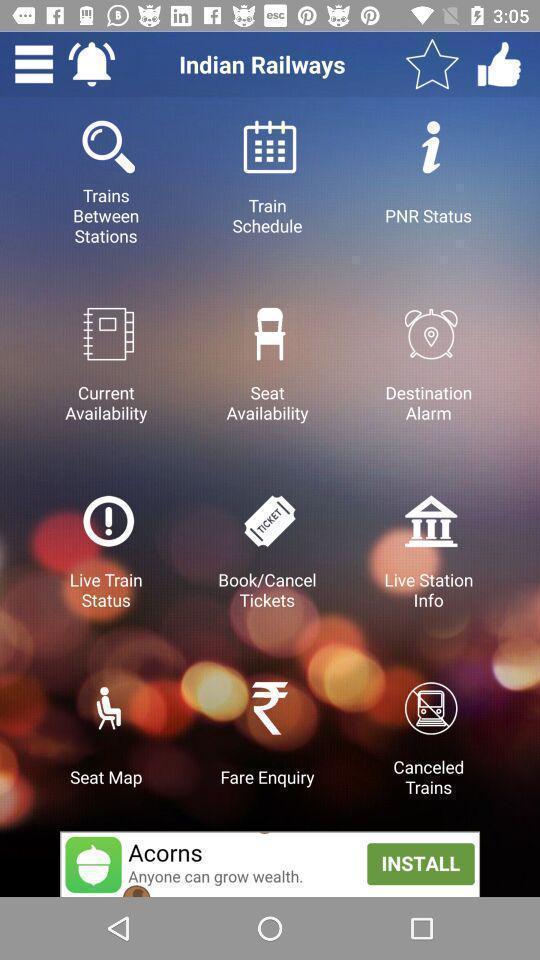Tell me what you see in this picture. Screen showing multiple options of a travel app. 